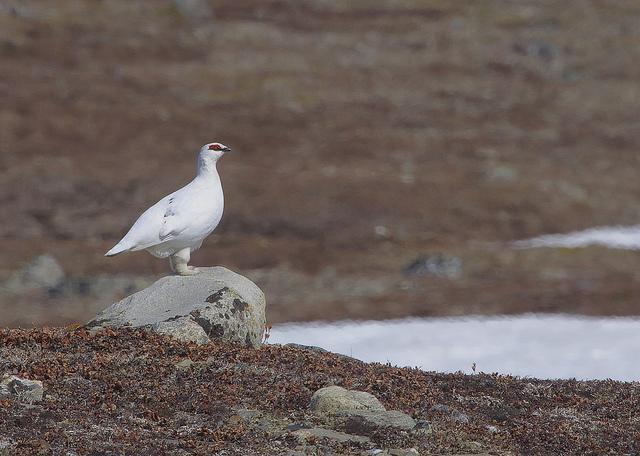How many birds are there?
Give a very brief answer. 1. How many birds are in the picture?
Give a very brief answer. 1. How many eggs are visible?
Give a very brief answer. 0. How many shirts is the girl wearing?
Give a very brief answer. 0. 